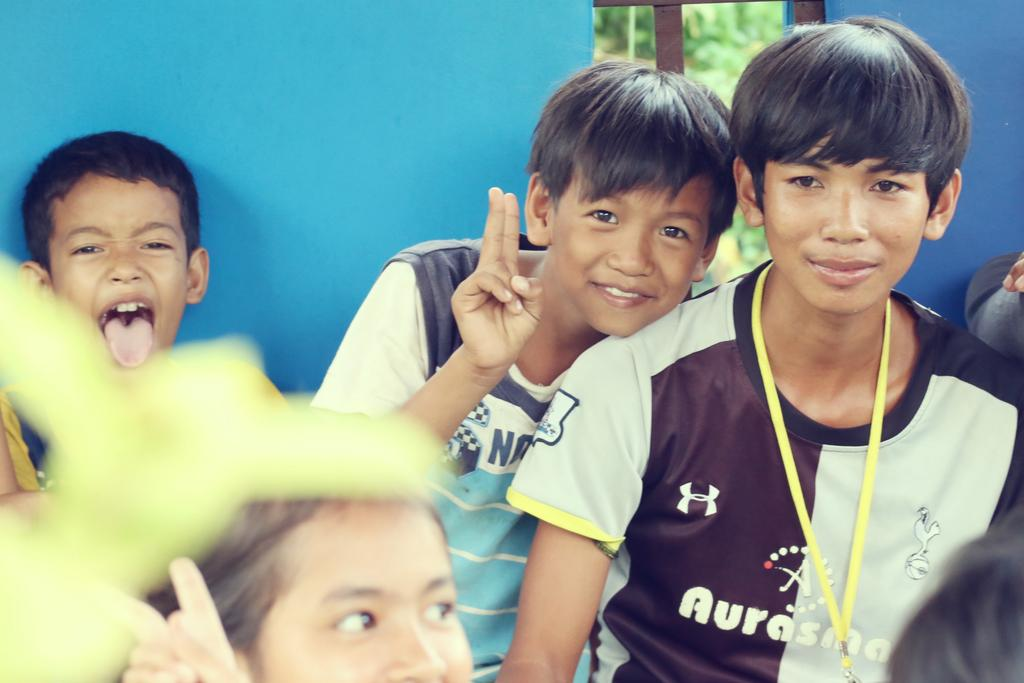What is the main subject of the image? The main subject of the image is the kids in the center. What is the expression on the kids' faces? The kids are smiling. What can be seen in the background of the image? There is a wall and a window in the background. What is visible through the window? Trees are visible behind the window. How many payments are being made by the kids in the image? There is no indication of any payments being made in the image; the focus is on the kids and their smiling expressions. What type of fold can be seen in the image? There is no fold present in the image; it features kids smiling and a background with a wall, window, and trees. 